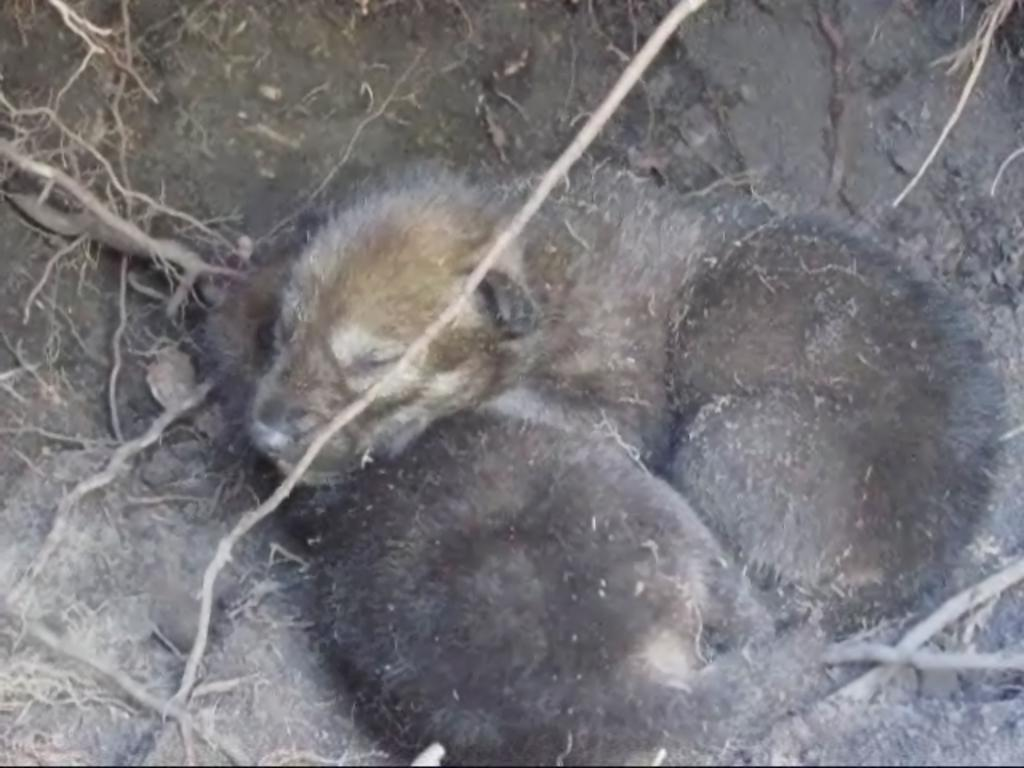What type of living organisms can be seen in the image? There are animals in the image. What are the animals doing in the image? The animals are sleeping. Where are the animals located in the image? The animals are on the ground. What type of book can be seen on the sleeping animals in the image? There is no book present in the image; it features animals sleeping on the ground. What kind of plant is growing on the animals in the image? There are no plants growing on the animals in the image; they are simply sleeping on the ground. 